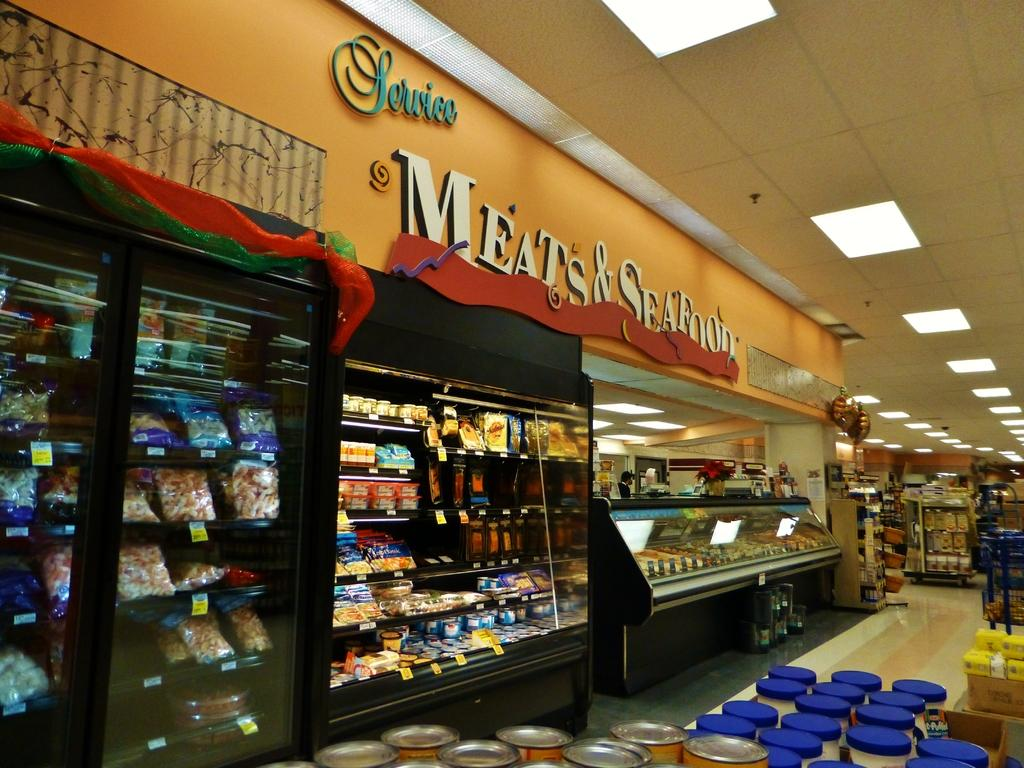Provide a one-sentence caption for the provided image. The frozen food section of a supermarket and wall says Service and Meat and Seafood. 